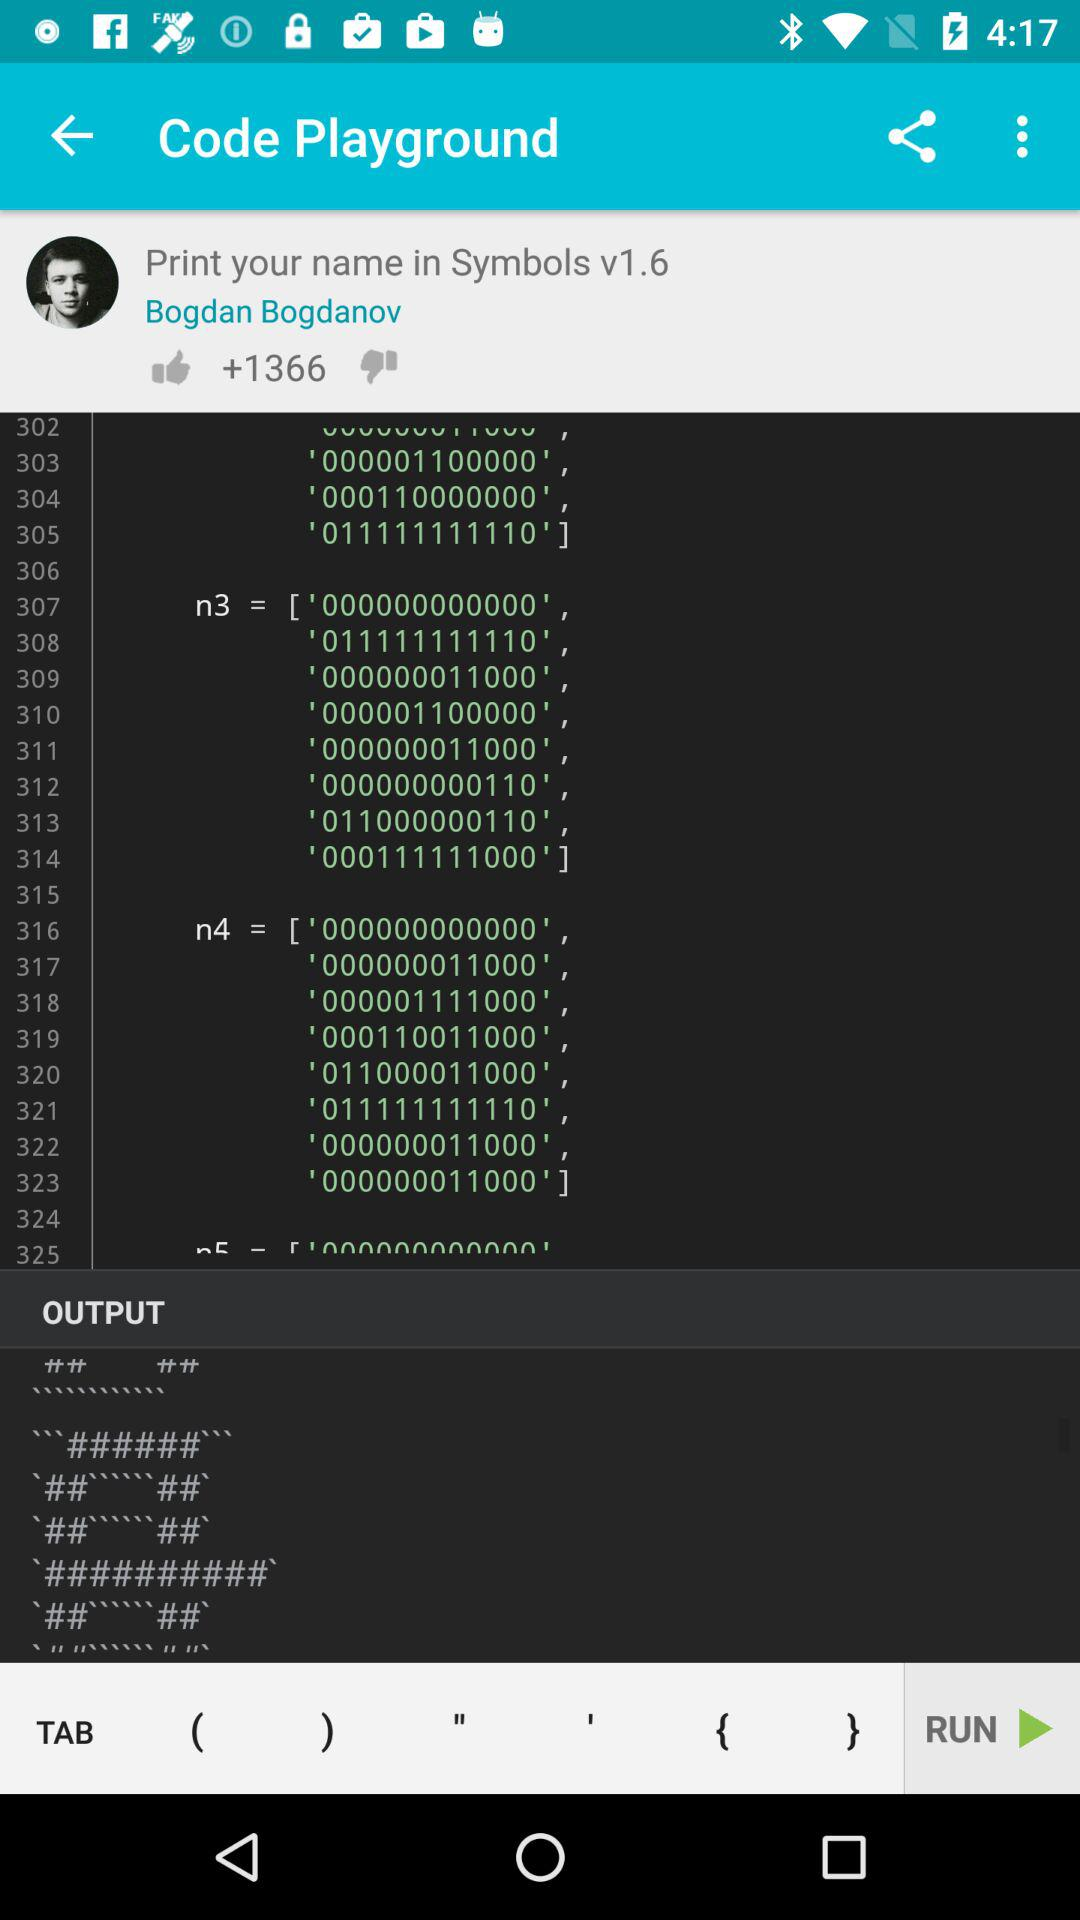How many likes are shown? The likes are +1366. 